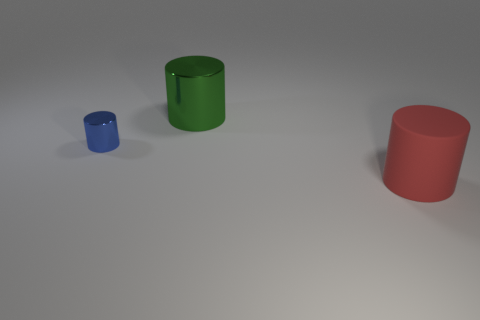Subtract all small shiny cylinders. How many cylinders are left? 2 Subtract 1 cylinders. How many cylinders are left? 2 Add 2 cylinders. How many objects exist? 5 Subtract all red cylinders. How many cylinders are left? 2 Subtract all red spheres. How many green cylinders are left? 1 Subtract all shiny cylinders. Subtract all large red matte cylinders. How many objects are left? 0 Add 2 cylinders. How many cylinders are left? 5 Add 2 tiny blue shiny cylinders. How many tiny blue shiny cylinders exist? 3 Subtract 0 gray cylinders. How many objects are left? 3 Subtract all red cylinders. Subtract all blue balls. How many cylinders are left? 2 